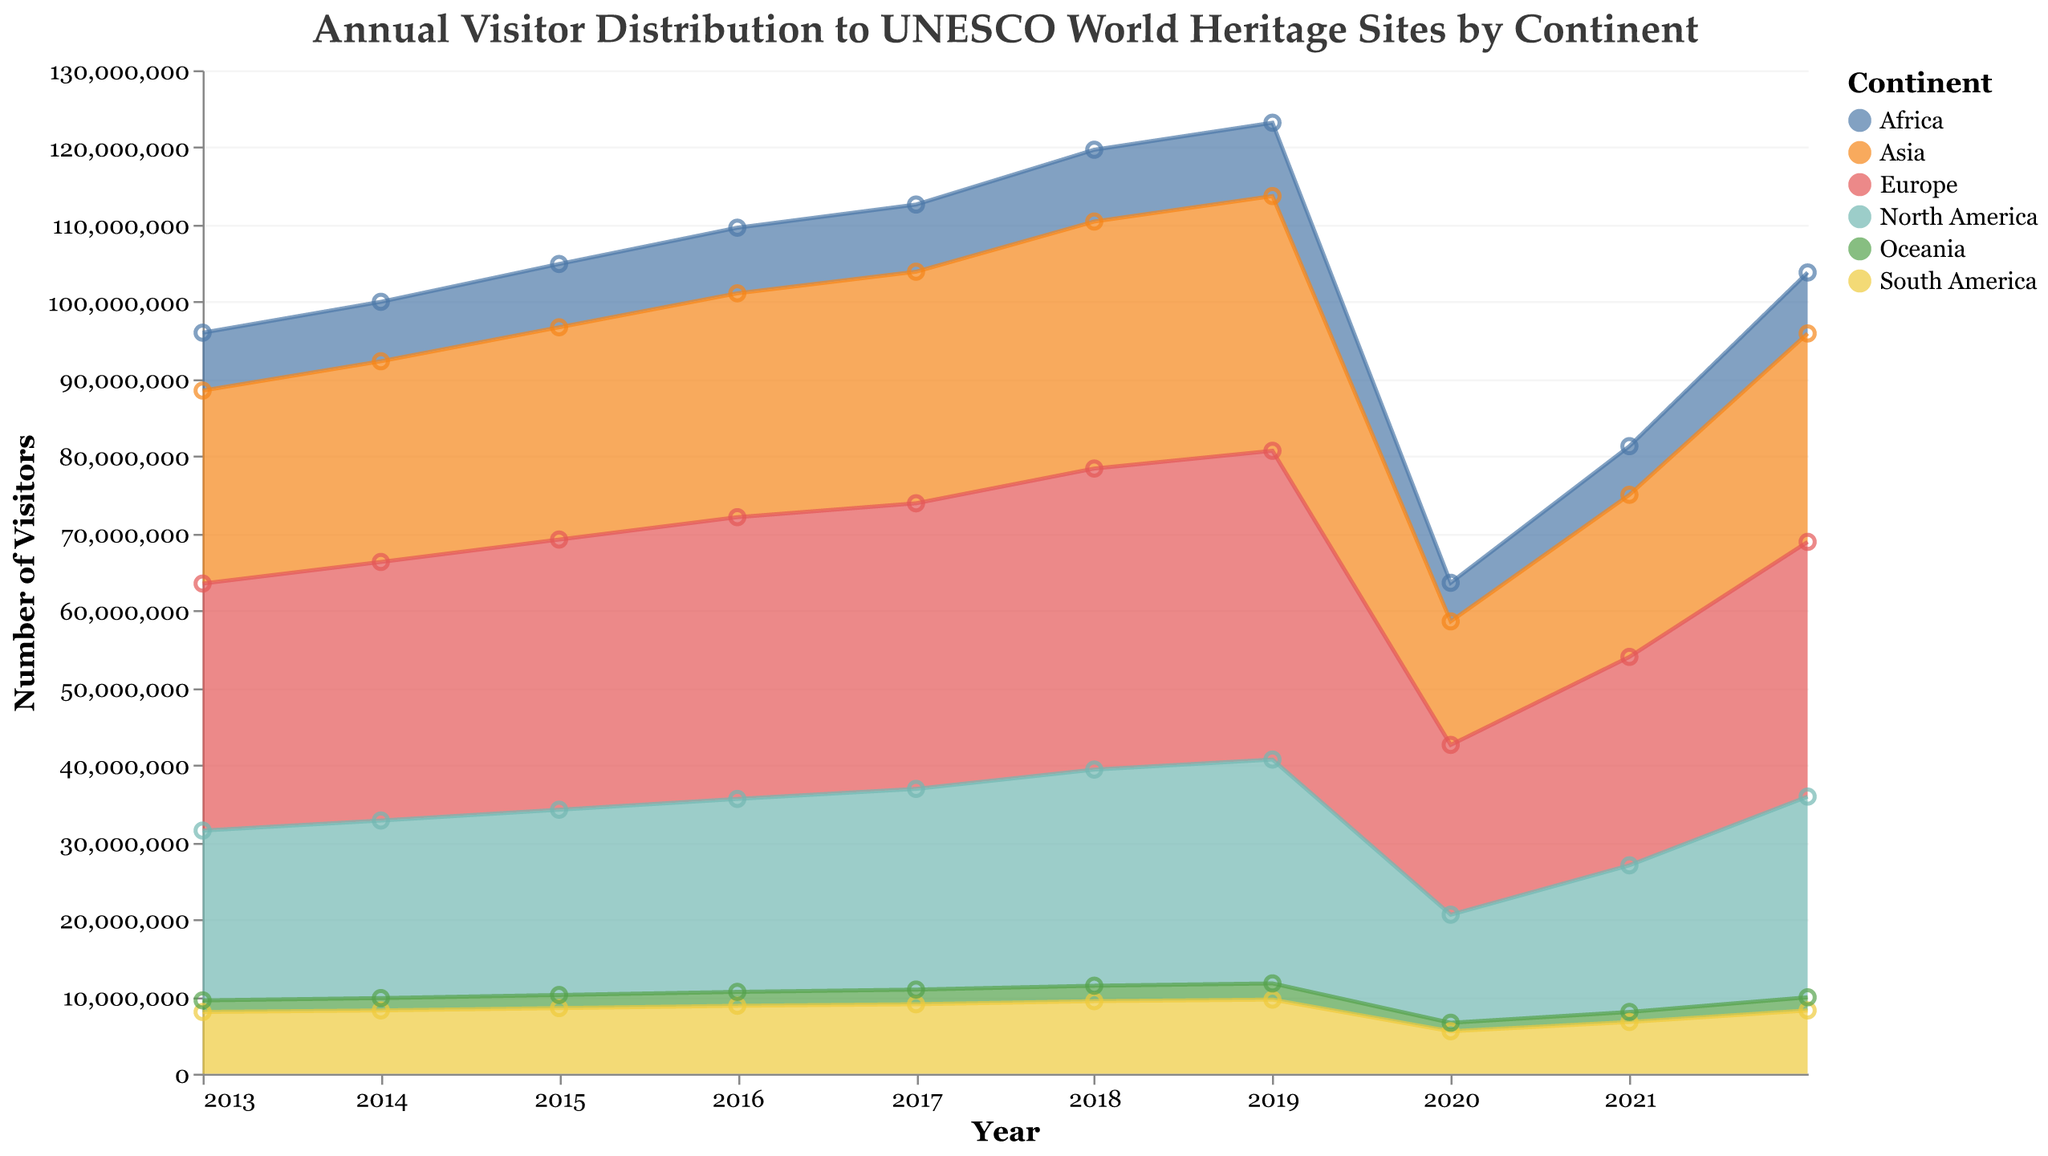What is the title of the chart? The title of the chart can be found at the top of the figure. It describes the overall topic of the chart.
Answer: Annual Visitor Distribution to UNESCO World Heritage Sites by Continent Which continent had the highest number of visitors in 2019? To determine the continent with the highest number of visitors in 2019, we need to look at the data points for each continent in that year and compare them. Europe has the highest data point in 2019.
Answer: Europe By how much did the number of visitors in Asia decrease from 2019 to 2020? To find this, subtract the number of visitors in Asia in 2020 from the number of visitors in Asia in 2019. The decrease is calculated as 33,000,000 - 16,000,000.
Answer: 17,000,000 What year saw the least visitors in North America over the decade? Look at the data points for North America across all years and identify the year with the lowest value. The minimum value is in 2020.
Answer: 2020 Which two continents had the closest number of visitors in 2022? Compare the number of visitors for each continent in 2022 and find the two continents with the smallest difference. Africa and South America are closest in visitor numbers.
Answer: Africa and South America What is the sum of visitors in all continents in 2020? Add the number of visitors for each continent in 2020: 5,000,000 (Africa) + 16,000,000 (Asia) + 22,000,000 (Europe) + 14,000,000 (North America) + 5,500,000 (South America) + 1,100,000 (Oceania).
Answer: 63,600,000 How did visitor numbers in Africa change from 2013 to 2022? Subtract the number of visitors in Africa in 2013 from the number in 2022: 7,900,000 - 7,500,000 = 400,000. Despite fluctuations, Africa ended with a slight increase over the decade.
Answer: Increased by 400,000 Which year experienced the sharpest decrease in visitors for any continent? Identify the year with the largest drop for any continent by examining the data points year-over-year. In 2020, most continents had sharp decreases due to the pandemic, with Europe experiencing a major drop from 40,000,000 to 22,000,000.
Answer: 2020 What is the average annual number of visitors to UNESCO sites in South America over the decade? Add the number of visitors in South America for each year from 2013 to 2022 and divide by the number of years (10). The average is approximately (8,000,000 + 8,200,000 + 8,500,000 + 8,800,000 + 9,000,000 + 9,400,000 + 9,600,000 + 5,500,000 + 6,700,000 + 8,200,000) / 10.
Answer: 8,090,000 How does the number of visitors in North America in 2021 compare to that in 2016? Subtract the number of visitors in North America in 2016 from that in 2021: 19,000,000 - 25,000,000, yielding a decrease of 6,000,000.
Answer: Decreased by 6,000,000 